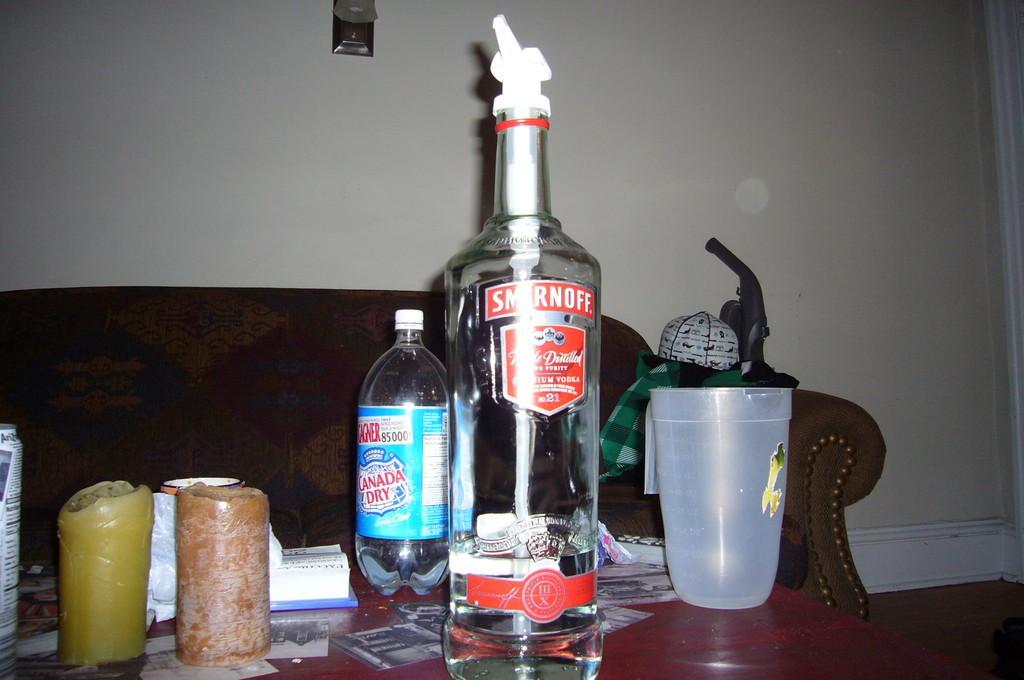Could you give a brief overview of what you see in this image? In the image in the center we can see vodka bottle,water bottle,glass and some more objects. Coming to the background we can see the couch and wall. 